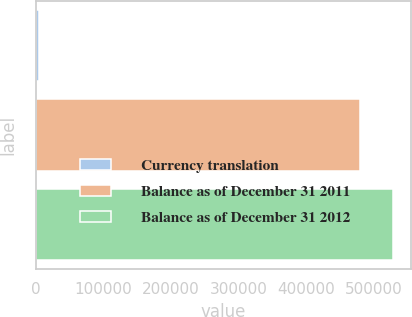<chart> <loc_0><loc_0><loc_500><loc_500><bar_chart><fcel>Currency translation<fcel>Balance as of December 31 2011<fcel>Balance as of December 31 2012<nl><fcel>5146<fcel>479402<fcel>527376<nl></chart> 